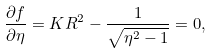<formula> <loc_0><loc_0><loc_500><loc_500>\frac { \partial f } { \partial \eta } = K R ^ { 2 } - \frac { 1 } { \sqrt { \eta ^ { 2 } - 1 } } = 0 ,</formula> 